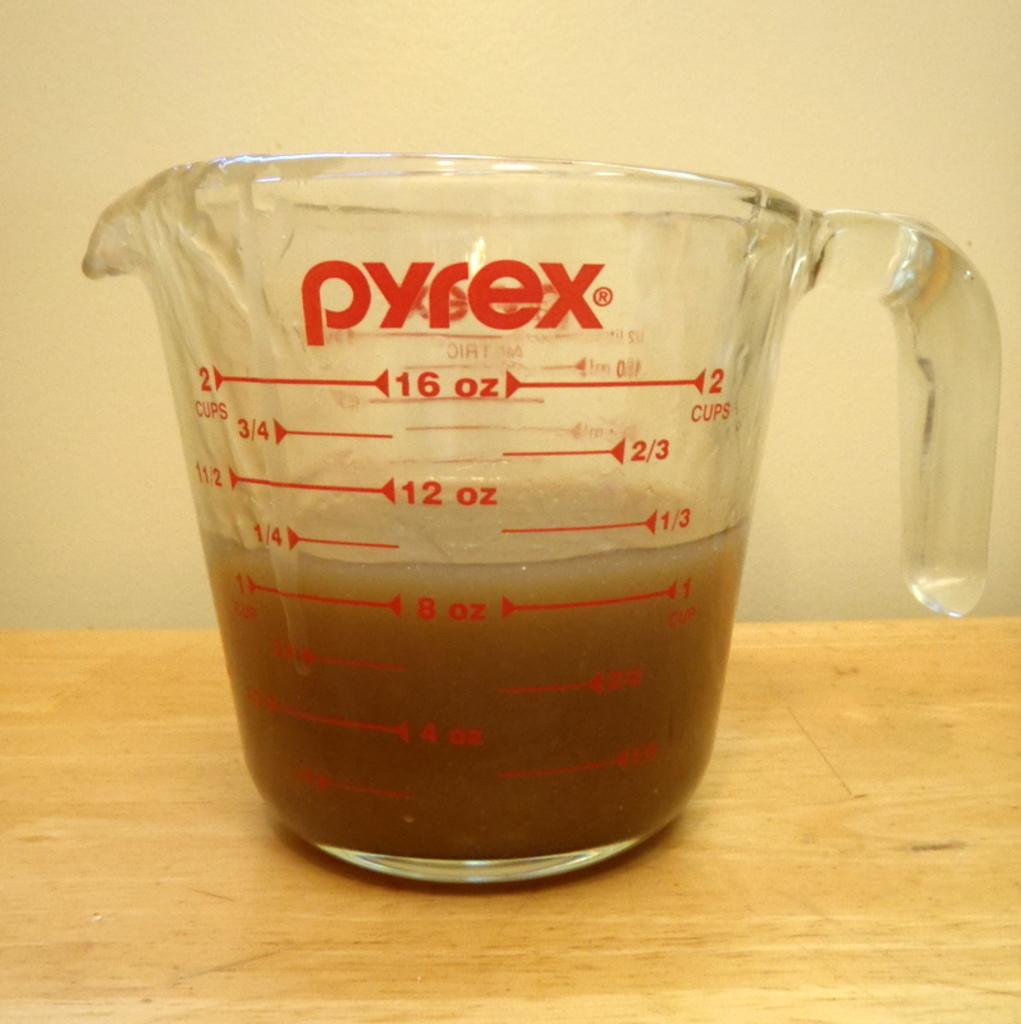Provide a one-sentence caption for the provided image. Pyrex measuring cup that have up to two cups to measure. 